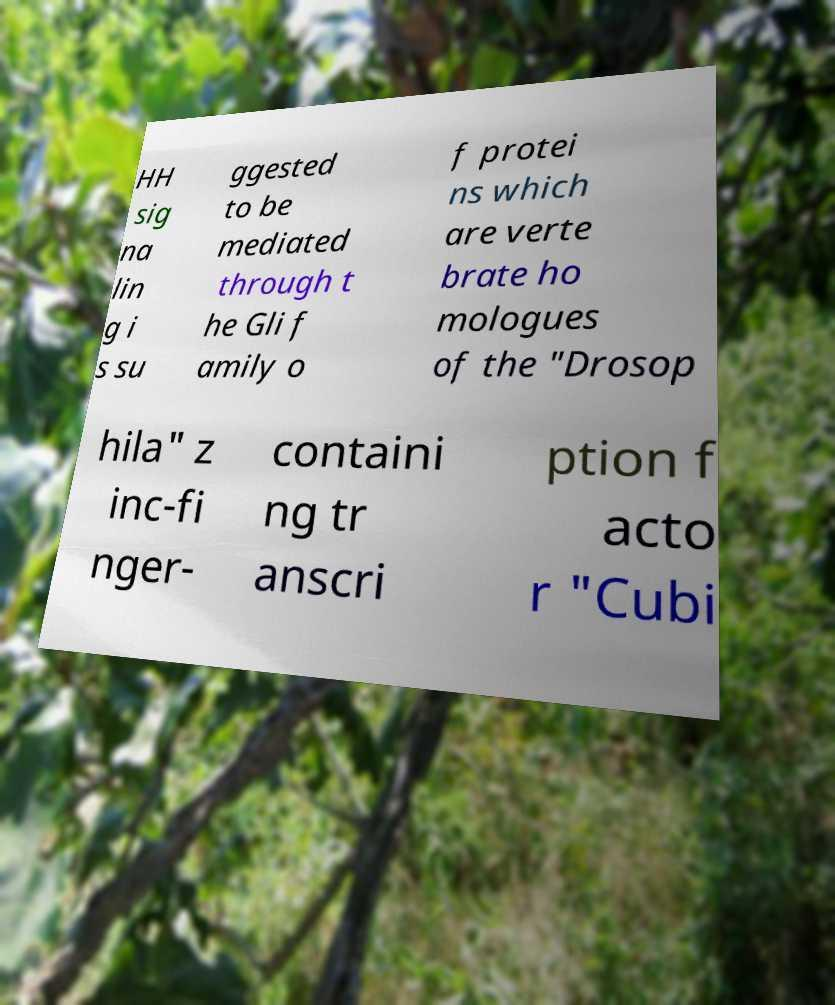Can you accurately transcribe the text from the provided image for me? HH sig na lin g i s su ggested to be mediated through t he Gli f amily o f protei ns which are verte brate ho mologues of the "Drosop hila" z inc-fi nger- containi ng tr anscri ption f acto r "Cubi 